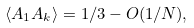Convert formula to latex. <formula><loc_0><loc_0><loc_500><loc_500>\langle A _ { 1 } A _ { k } \rangle = 1 / 3 - O ( 1 / N ) ,</formula> 